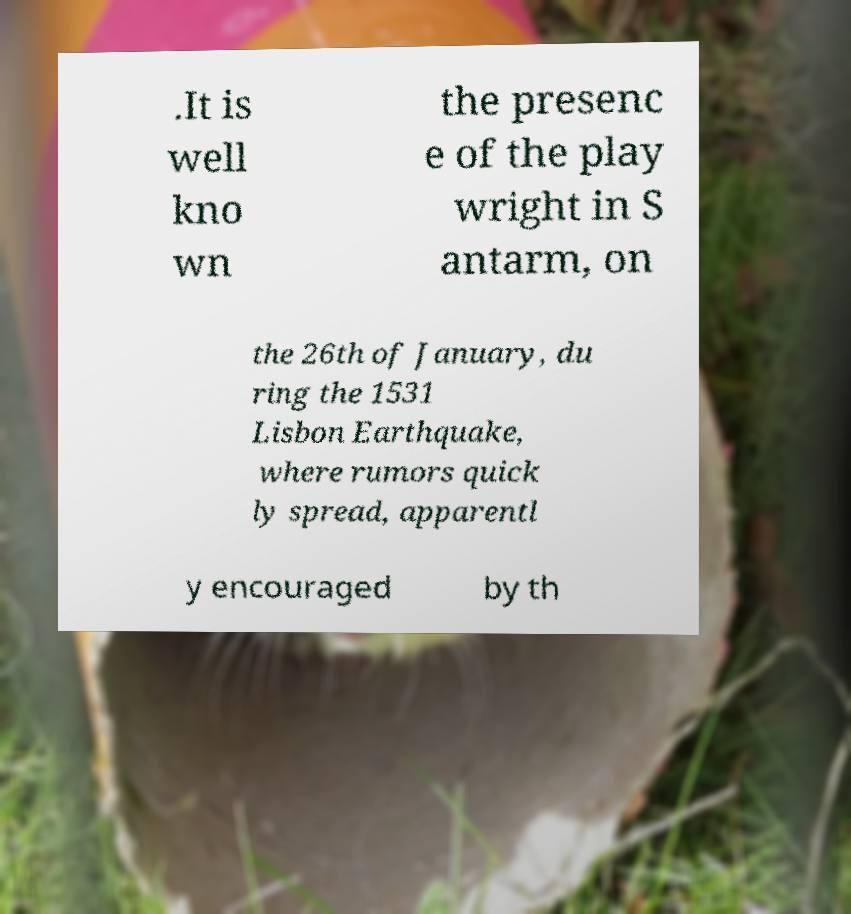There's text embedded in this image that I need extracted. Can you transcribe it verbatim? .It is well kno wn the presenc e of the play wright in S antarm, on the 26th of January, du ring the 1531 Lisbon Earthquake, where rumors quick ly spread, apparentl y encouraged by th 